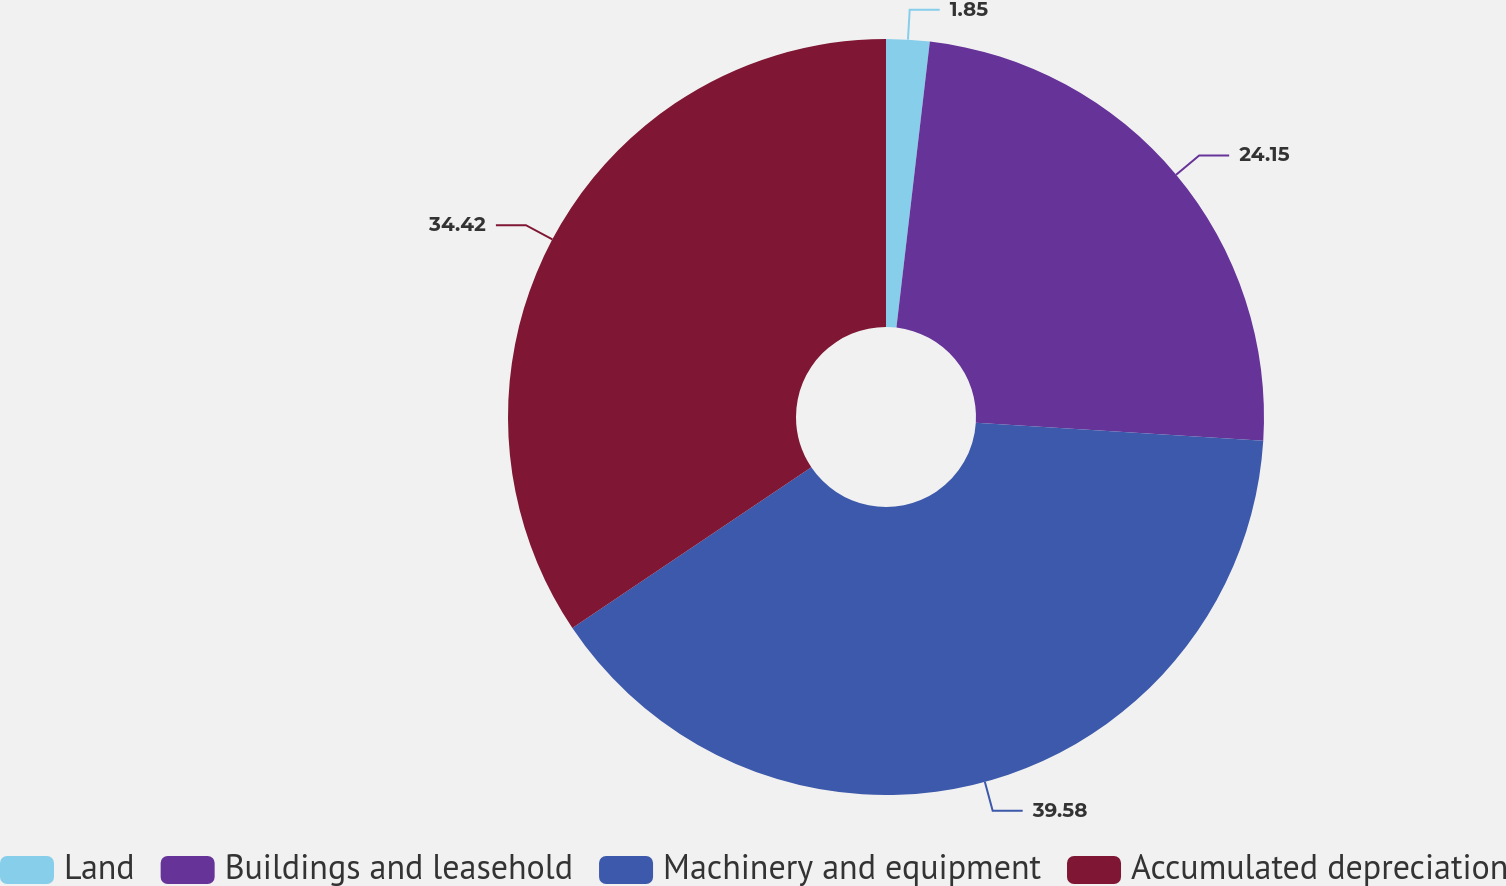<chart> <loc_0><loc_0><loc_500><loc_500><pie_chart><fcel>Land<fcel>Buildings and leasehold<fcel>Machinery and equipment<fcel>Accumulated depreciation<nl><fcel>1.85%<fcel>24.15%<fcel>39.57%<fcel>34.42%<nl></chart> 